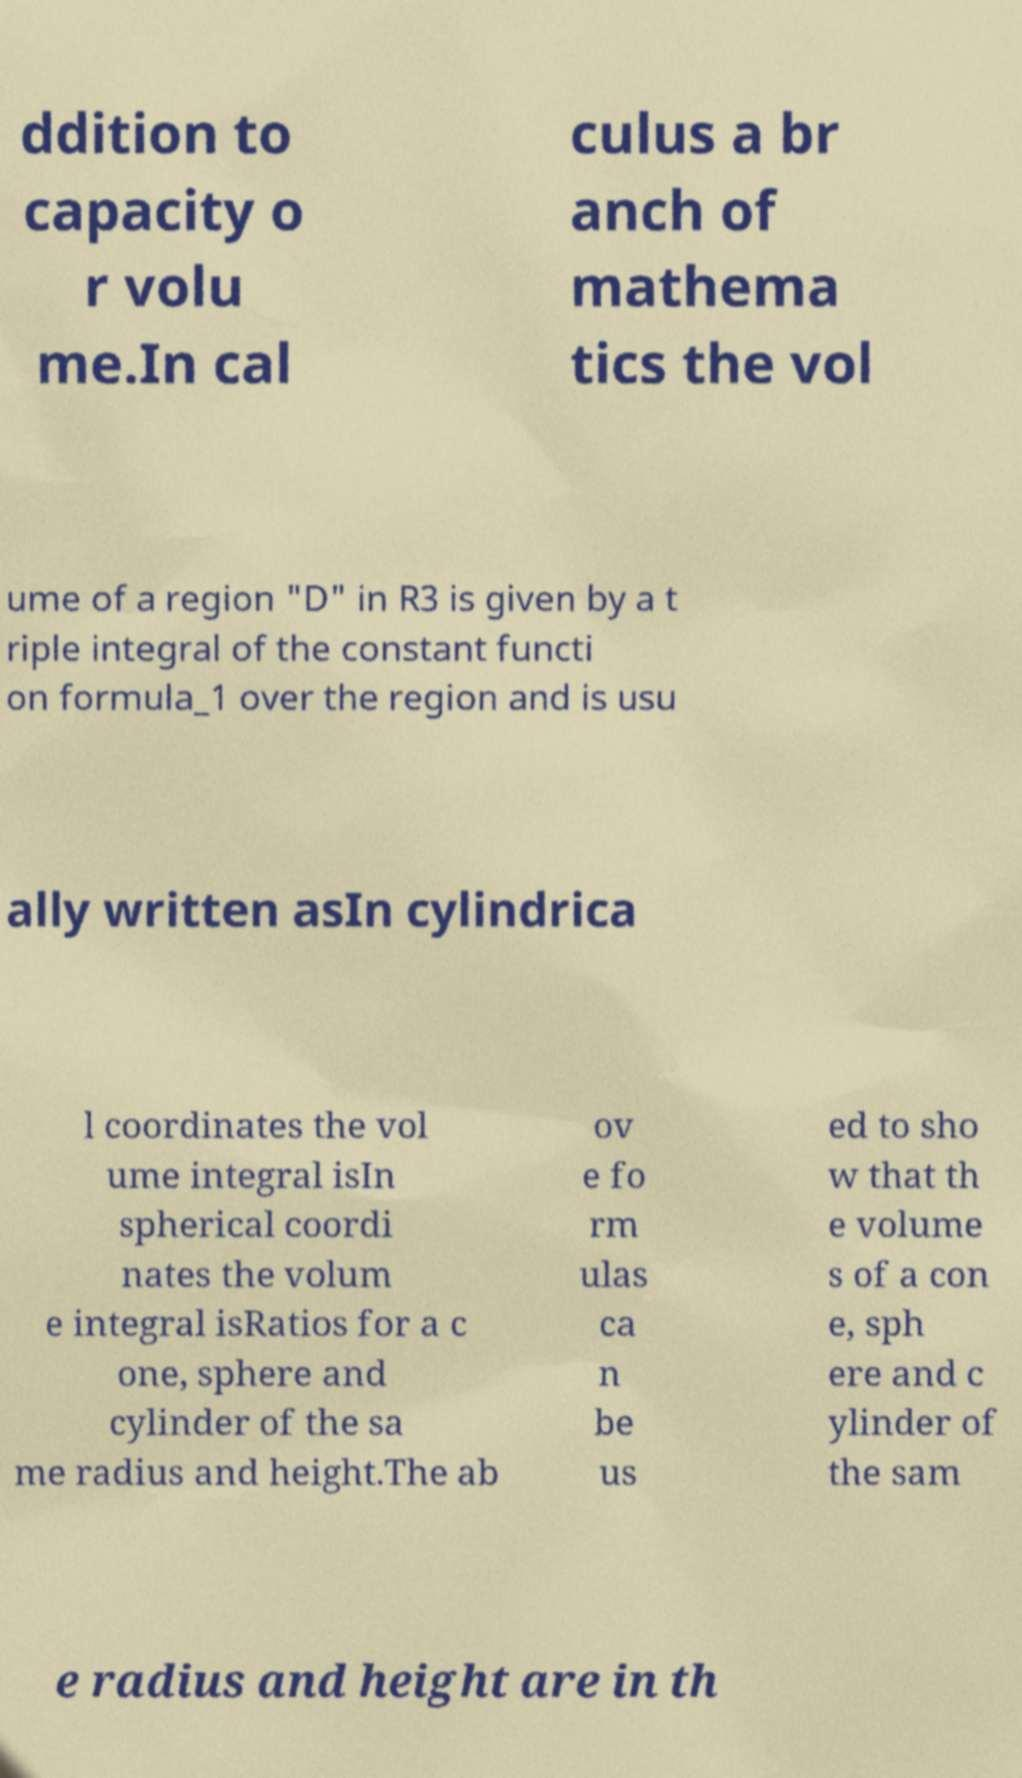Can you accurately transcribe the text from the provided image for me? ddition to capacity o r volu me.In cal culus a br anch of mathema tics the vol ume of a region "D" in R3 is given by a t riple integral of the constant functi on formula_1 over the region and is usu ally written asIn cylindrica l coordinates the vol ume integral isIn spherical coordi nates the volum e integral isRatios for a c one, sphere and cylinder of the sa me radius and height.The ab ov e fo rm ulas ca n be us ed to sho w that th e volume s of a con e, sph ere and c ylinder of the sam e radius and height are in th 